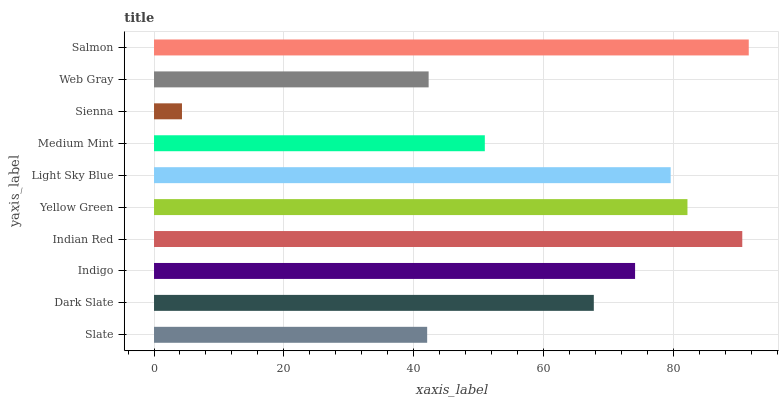Is Sienna the minimum?
Answer yes or no. Yes. Is Salmon the maximum?
Answer yes or no. Yes. Is Dark Slate the minimum?
Answer yes or no. No. Is Dark Slate the maximum?
Answer yes or no. No. Is Dark Slate greater than Slate?
Answer yes or no. Yes. Is Slate less than Dark Slate?
Answer yes or no. Yes. Is Slate greater than Dark Slate?
Answer yes or no. No. Is Dark Slate less than Slate?
Answer yes or no. No. Is Indigo the high median?
Answer yes or no. Yes. Is Dark Slate the low median?
Answer yes or no. Yes. Is Indian Red the high median?
Answer yes or no. No. Is Slate the low median?
Answer yes or no. No. 